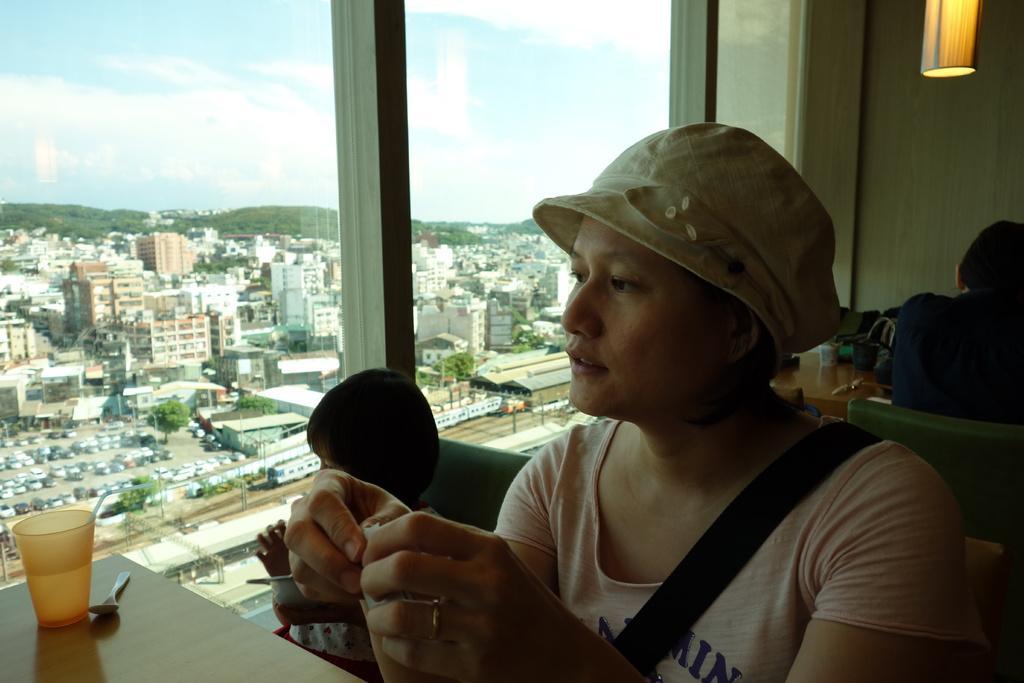Could you give a brief overview of what you see in this image? In this image I see a woman and a child who are sitting on chairs and I see this woman is holding a thing in her hands and I see the table on which there is a cup and a spoon beside to it and I see another person who is sitting on a chair and I see another table over here and I see the wall and I see the light over here. I can also see the windows and through the glasses I see number of buildings, trees, cars and I see the clear sky. 